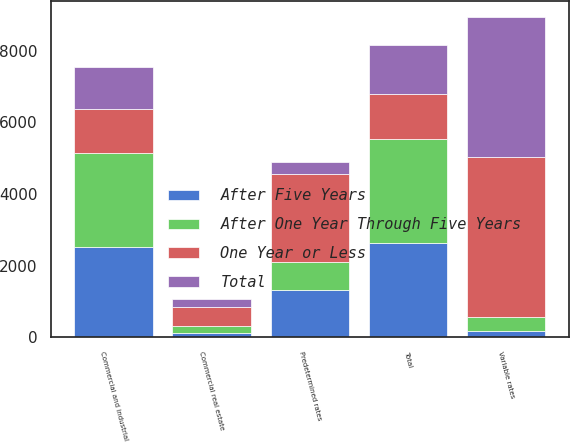<chart> <loc_0><loc_0><loc_500><loc_500><stacked_bar_chart><ecel><fcel>Commercial and industrial<fcel>Commercial real estate<fcel>Total<fcel>Variable rates<fcel>Predetermined rates<nl><fcel>Total<fcel>1159.6<fcel>210.6<fcel>1379<fcel>3926.8<fcel>353.8<nl><fcel>After One Year Through Five Years<fcel>2627.2<fcel>197.7<fcel>2908.1<fcel>382.7<fcel>790<nl><fcel>After Five Years<fcel>2515.3<fcel>123.8<fcel>2639.1<fcel>164.8<fcel>1308.1<nl><fcel>One Year or Less<fcel>1233.85<fcel>532.1<fcel>1233.85<fcel>4474.3<fcel>2451.9<nl></chart> 